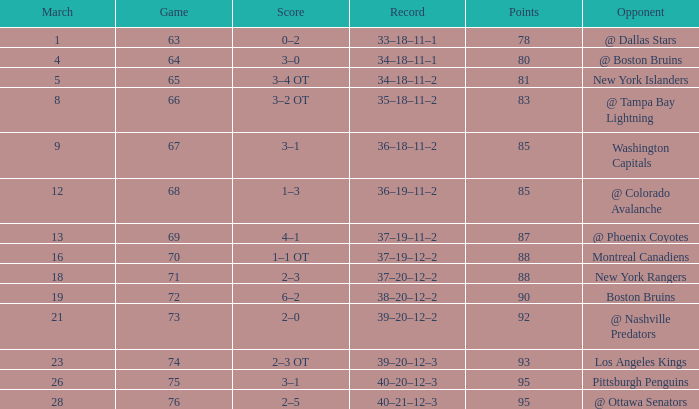Which Opponent has a Record of 38–20–12–2? Boston Bruins. 